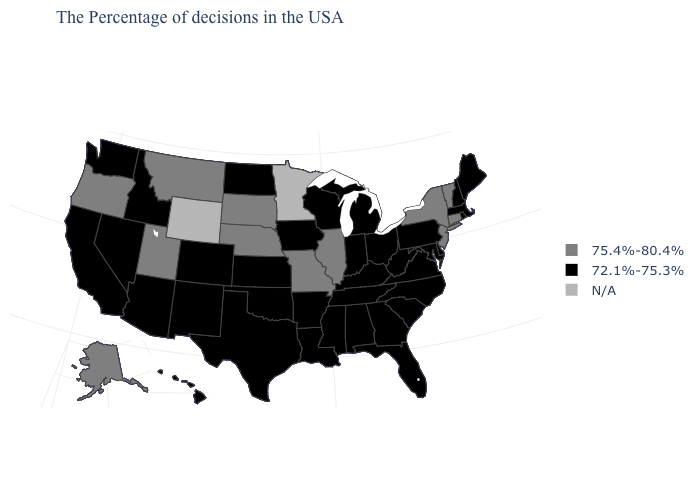Among the states that border New Jersey , does Pennsylvania have the highest value?
Be succinct. No. What is the value of New Hampshire?
Write a very short answer. 72.1%-75.3%. Among the states that border Arkansas , which have the highest value?
Write a very short answer. Missouri. What is the lowest value in the USA?
Keep it brief. 72.1%-75.3%. Name the states that have a value in the range 72.1%-75.3%?
Be succinct. Maine, Massachusetts, Rhode Island, New Hampshire, Delaware, Maryland, Pennsylvania, Virginia, North Carolina, South Carolina, West Virginia, Ohio, Florida, Georgia, Michigan, Kentucky, Indiana, Alabama, Tennessee, Wisconsin, Mississippi, Louisiana, Arkansas, Iowa, Kansas, Oklahoma, Texas, North Dakota, Colorado, New Mexico, Arizona, Idaho, Nevada, California, Washington, Hawaii. Among the states that border Idaho , does Oregon have the highest value?
Write a very short answer. Yes. Does the map have missing data?
Be succinct. Yes. Does the first symbol in the legend represent the smallest category?
Be succinct. No. Among the states that border Montana , which have the lowest value?
Give a very brief answer. North Dakota, Idaho. What is the value of Maine?
Write a very short answer. 72.1%-75.3%. Name the states that have a value in the range 75.4%-80.4%?
Give a very brief answer. Vermont, Connecticut, New York, New Jersey, Illinois, Missouri, Nebraska, South Dakota, Utah, Montana, Oregon, Alaska. Does Missouri have the highest value in the USA?
Write a very short answer. Yes. What is the value of Arizona?
Quick response, please. 72.1%-75.3%. Name the states that have a value in the range 75.4%-80.4%?
Quick response, please. Vermont, Connecticut, New York, New Jersey, Illinois, Missouri, Nebraska, South Dakota, Utah, Montana, Oregon, Alaska. 